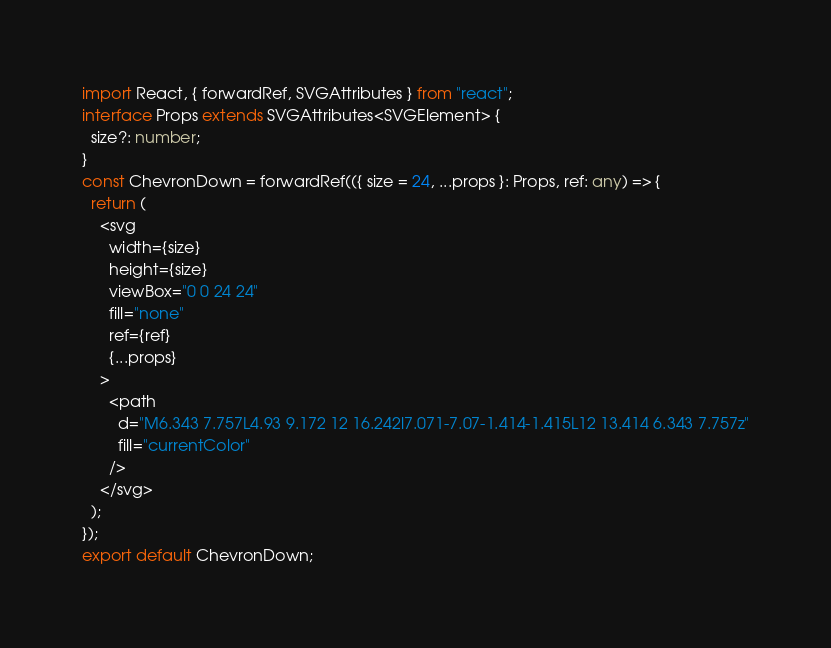<code> <loc_0><loc_0><loc_500><loc_500><_TypeScript_>import React, { forwardRef, SVGAttributes } from "react";
interface Props extends SVGAttributes<SVGElement> {
  size?: number;
}
const ChevronDown = forwardRef(({ size = 24, ...props }: Props, ref: any) => {
  return (
    <svg
      width={size}
      height={size}
      viewBox="0 0 24 24"
      fill="none"
      ref={ref}
      {...props}
    >
      <path
        d="M6.343 7.757L4.93 9.172 12 16.242l7.071-7.07-1.414-1.415L12 13.414 6.343 7.757z"
        fill="currentColor"
      />
    </svg>
  );
});
export default ChevronDown;
</code> 